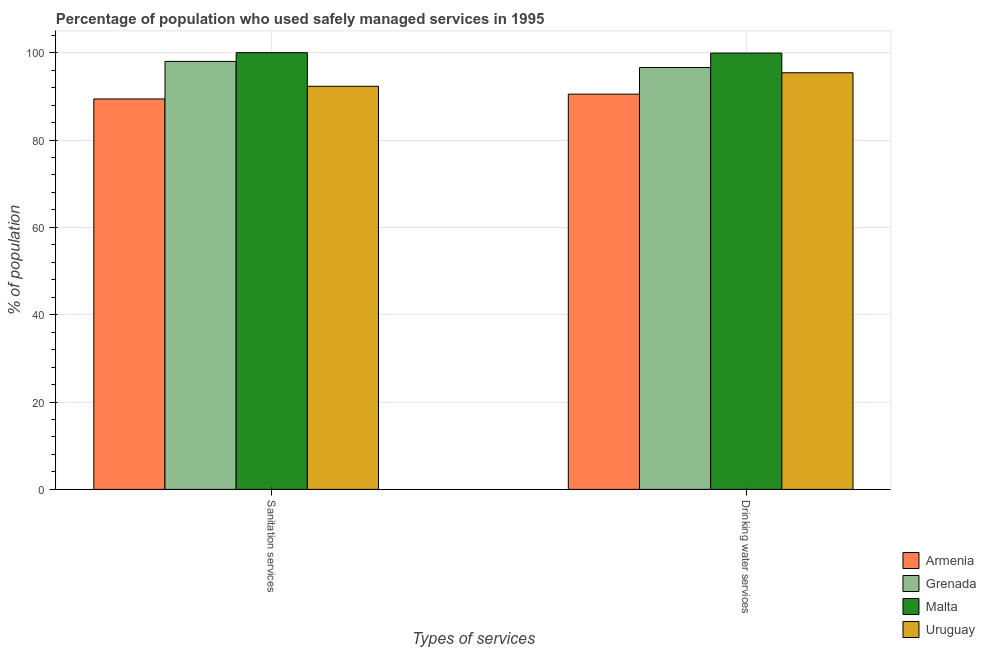Are the number of bars per tick equal to the number of legend labels?
Provide a short and direct response. Yes. Are the number of bars on each tick of the X-axis equal?
Offer a very short reply. Yes. What is the label of the 1st group of bars from the left?
Offer a very short reply. Sanitation services. What is the percentage of population who used drinking water services in Malta?
Your answer should be very brief. 99.9. Across all countries, what is the maximum percentage of population who used sanitation services?
Your answer should be compact. 100. Across all countries, what is the minimum percentage of population who used drinking water services?
Offer a terse response. 90.5. In which country was the percentage of population who used sanitation services maximum?
Offer a very short reply. Malta. In which country was the percentage of population who used sanitation services minimum?
Provide a short and direct response. Armenia. What is the total percentage of population who used sanitation services in the graph?
Offer a terse response. 379.7. What is the difference between the percentage of population who used drinking water services in Malta and that in Uruguay?
Provide a short and direct response. 4.5. What is the average percentage of population who used drinking water services per country?
Provide a short and direct response. 95.6. What is the difference between the percentage of population who used drinking water services and percentage of population who used sanitation services in Armenia?
Provide a short and direct response. 1.1. What is the ratio of the percentage of population who used drinking water services in Uruguay to that in Malta?
Offer a terse response. 0.95. In how many countries, is the percentage of population who used sanitation services greater than the average percentage of population who used sanitation services taken over all countries?
Your answer should be compact. 2. What does the 3rd bar from the left in Drinking water services represents?
Ensure brevity in your answer.  Malta. What does the 2nd bar from the right in Sanitation services represents?
Provide a short and direct response. Malta. What is the difference between two consecutive major ticks on the Y-axis?
Give a very brief answer. 20. Where does the legend appear in the graph?
Provide a succinct answer. Bottom right. What is the title of the graph?
Ensure brevity in your answer.  Percentage of population who used safely managed services in 1995. Does "Malaysia" appear as one of the legend labels in the graph?
Provide a succinct answer. No. What is the label or title of the X-axis?
Make the answer very short. Types of services. What is the label or title of the Y-axis?
Offer a very short reply. % of population. What is the % of population in Armenia in Sanitation services?
Make the answer very short. 89.4. What is the % of population in Malta in Sanitation services?
Provide a short and direct response. 100. What is the % of population of Uruguay in Sanitation services?
Your response must be concise. 92.3. What is the % of population of Armenia in Drinking water services?
Ensure brevity in your answer.  90.5. What is the % of population of Grenada in Drinking water services?
Provide a succinct answer. 96.6. What is the % of population of Malta in Drinking water services?
Your answer should be very brief. 99.9. What is the % of population of Uruguay in Drinking water services?
Offer a very short reply. 95.4. Across all Types of services, what is the maximum % of population of Armenia?
Provide a short and direct response. 90.5. Across all Types of services, what is the maximum % of population in Grenada?
Your response must be concise. 98. Across all Types of services, what is the maximum % of population of Uruguay?
Your response must be concise. 95.4. Across all Types of services, what is the minimum % of population in Armenia?
Provide a short and direct response. 89.4. Across all Types of services, what is the minimum % of population of Grenada?
Your answer should be compact. 96.6. Across all Types of services, what is the minimum % of population of Malta?
Make the answer very short. 99.9. Across all Types of services, what is the minimum % of population of Uruguay?
Your response must be concise. 92.3. What is the total % of population of Armenia in the graph?
Keep it short and to the point. 179.9. What is the total % of population in Grenada in the graph?
Ensure brevity in your answer.  194.6. What is the total % of population of Malta in the graph?
Offer a terse response. 199.9. What is the total % of population of Uruguay in the graph?
Your answer should be very brief. 187.7. What is the difference between the % of population in Armenia in Sanitation services and that in Drinking water services?
Keep it short and to the point. -1.1. What is the difference between the % of population in Uruguay in Sanitation services and that in Drinking water services?
Make the answer very short. -3.1. What is the difference between the % of population in Armenia in Sanitation services and the % of population in Grenada in Drinking water services?
Give a very brief answer. -7.2. What is the difference between the % of population of Armenia in Sanitation services and the % of population of Malta in Drinking water services?
Keep it short and to the point. -10.5. What is the difference between the % of population in Armenia in Sanitation services and the % of population in Uruguay in Drinking water services?
Ensure brevity in your answer.  -6. What is the difference between the % of population in Grenada in Sanitation services and the % of population in Malta in Drinking water services?
Keep it short and to the point. -1.9. What is the difference between the % of population in Grenada in Sanitation services and the % of population in Uruguay in Drinking water services?
Provide a short and direct response. 2.6. What is the difference between the % of population of Malta in Sanitation services and the % of population of Uruguay in Drinking water services?
Offer a terse response. 4.6. What is the average % of population of Armenia per Types of services?
Offer a terse response. 89.95. What is the average % of population in Grenada per Types of services?
Offer a terse response. 97.3. What is the average % of population in Malta per Types of services?
Make the answer very short. 99.95. What is the average % of population in Uruguay per Types of services?
Offer a terse response. 93.85. What is the difference between the % of population of Armenia and % of population of Malta in Sanitation services?
Provide a succinct answer. -10.6. What is the difference between the % of population of Grenada and % of population of Malta in Sanitation services?
Provide a succinct answer. -2. What is the difference between the % of population of Malta and % of population of Uruguay in Sanitation services?
Give a very brief answer. 7.7. What is the difference between the % of population of Armenia and % of population of Grenada in Drinking water services?
Make the answer very short. -6.1. What is the difference between the % of population of Armenia and % of population of Uruguay in Drinking water services?
Your response must be concise. -4.9. What is the difference between the % of population of Grenada and % of population of Malta in Drinking water services?
Your answer should be compact. -3.3. What is the difference between the % of population in Malta and % of population in Uruguay in Drinking water services?
Provide a short and direct response. 4.5. What is the ratio of the % of population in Grenada in Sanitation services to that in Drinking water services?
Offer a terse response. 1.01. What is the ratio of the % of population in Malta in Sanitation services to that in Drinking water services?
Provide a succinct answer. 1. What is the ratio of the % of population of Uruguay in Sanitation services to that in Drinking water services?
Provide a succinct answer. 0.97. What is the difference between the highest and the second highest % of population in Uruguay?
Offer a terse response. 3.1. What is the difference between the highest and the lowest % of population in Grenada?
Ensure brevity in your answer.  1.4. What is the difference between the highest and the lowest % of population in Malta?
Give a very brief answer. 0.1. 